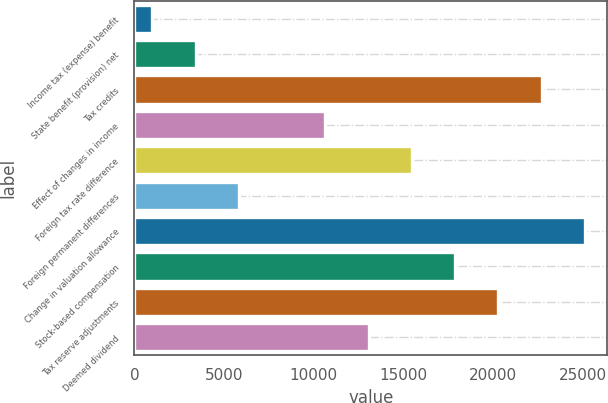<chart> <loc_0><loc_0><loc_500><loc_500><bar_chart><fcel>Income tax (expense) benefit<fcel>State benefit (provision) net<fcel>Tax credits<fcel>Effect of changes in income<fcel>Foreign tax rate difference<fcel>Foreign permanent differences<fcel>Change in valuation allowance<fcel>Stock-based compensation<fcel>Tax reserve adjustments<fcel>Deemed dividend<nl><fcel>1002<fcel>3413.8<fcel>22708.2<fcel>10649.2<fcel>15472.8<fcel>5825.6<fcel>25120<fcel>17884.6<fcel>20296.4<fcel>13061<nl></chart> 